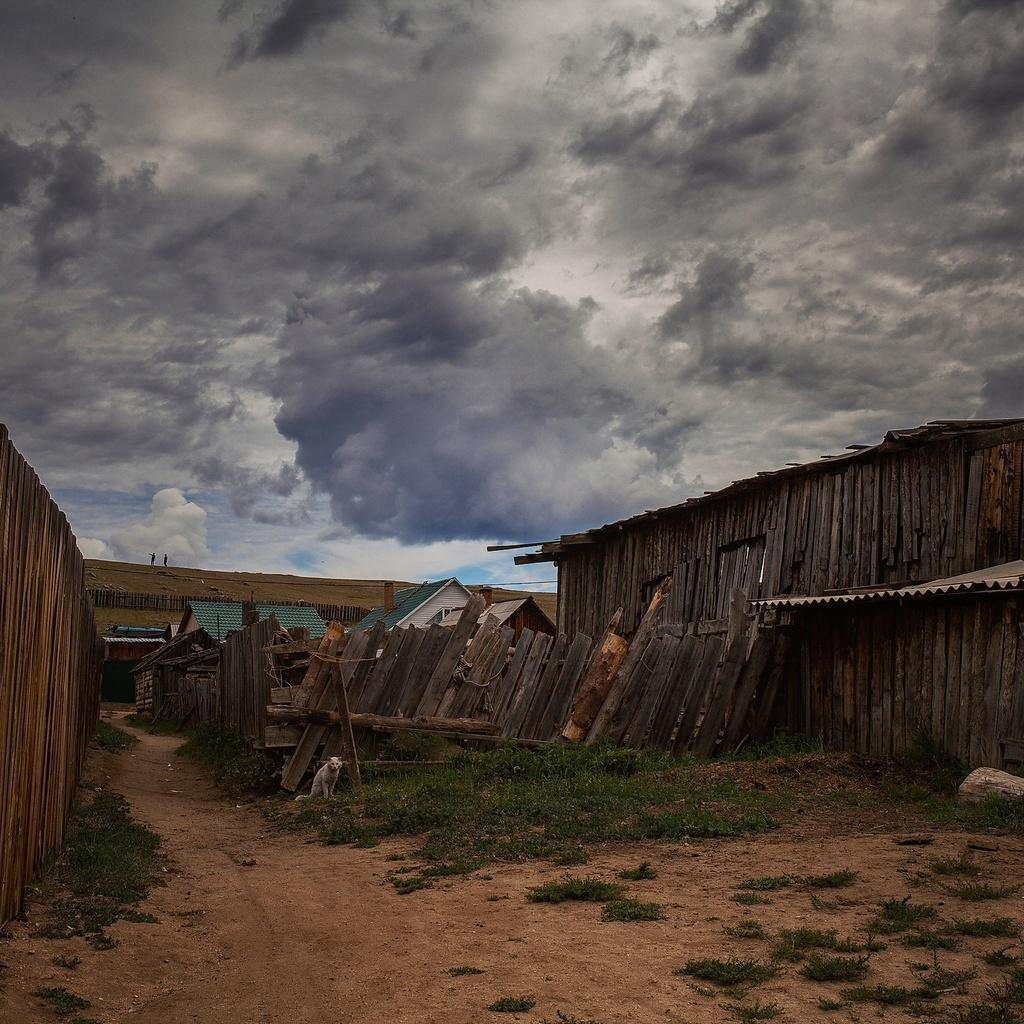What is on the path in the image? There is an animal on the path in the image. What type of objects are behind the animal? There are wooden objects behind the animal. What can be seen in the distance in the image? There are houses visible in the background. What is the material of the fence in the background? The fence in the background is made of wood. What part of the natural environment is visible in the image? The sky is visible in the image. How does the mist affect the visibility of the goat in the image? There is no mist present in the image, so it does not affect the visibility of the goat. What type of dust can be seen on the wooden objects in the image? There is no dust visible on the wooden objects in the image. 